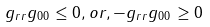Convert formula to latex. <formula><loc_0><loc_0><loc_500><loc_500>g _ { r r } g _ { 0 0 } \leq 0 , o r , - g _ { r r } g _ { 0 0 } \geq 0</formula> 